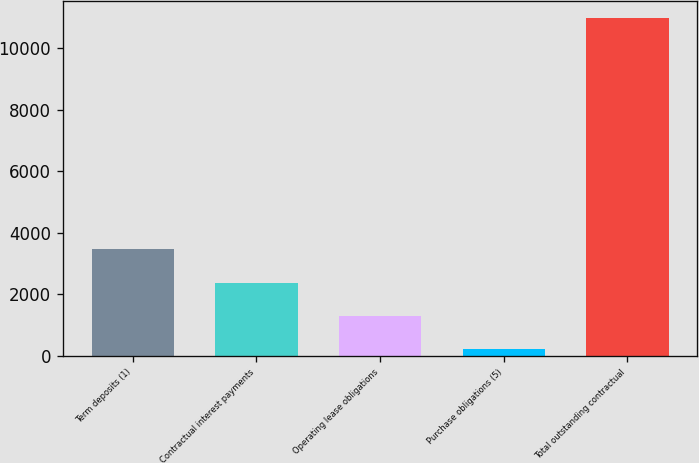Convert chart. <chart><loc_0><loc_0><loc_500><loc_500><bar_chart><fcel>Term deposits (1)<fcel>Contractual interest payments<fcel>Operating lease obligations<fcel>Purchase obligations (5)<fcel>Total outstanding contractual<nl><fcel>3462.7<fcel>2386.8<fcel>1310.9<fcel>235<fcel>10994<nl></chart> 